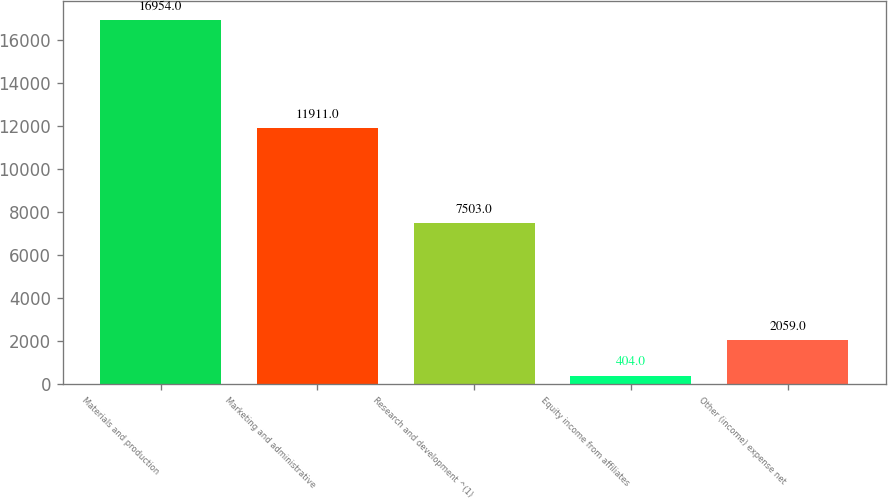Convert chart to OTSL. <chart><loc_0><loc_0><loc_500><loc_500><bar_chart><fcel>Materials and production<fcel>Marketing and administrative<fcel>Research and development ^(1)<fcel>Equity income from affiliates<fcel>Other (income) expense net<nl><fcel>16954<fcel>11911<fcel>7503<fcel>404<fcel>2059<nl></chart> 